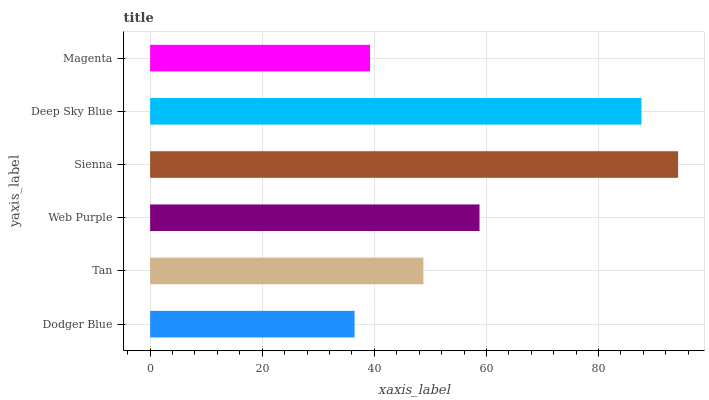Is Dodger Blue the minimum?
Answer yes or no. Yes. Is Sienna the maximum?
Answer yes or no. Yes. Is Tan the minimum?
Answer yes or no. No. Is Tan the maximum?
Answer yes or no. No. Is Tan greater than Dodger Blue?
Answer yes or no. Yes. Is Dodger Blue less than Tan?
Answer yes or no. Yes. Is Dodger Blue greater than Tan?
Answer yes or no. No. Is Tan less than Dodger Blue?
Answer yes or no. No. Is Web Purple the high median?
Answer yes or no. Yes. Is Tan the low median?
Answer yes or no. Yes. Is Sienna the high median?
Answer yes or no. No. Is Sienna the low median?
Answer yes or no. No. 